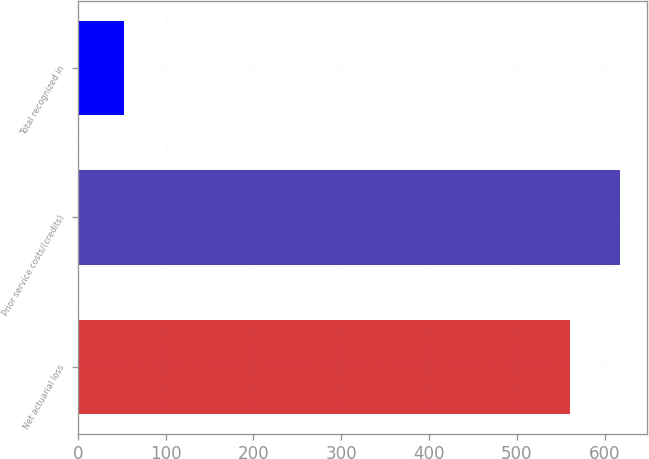Convert chart to OTSL. <chart><loc_0><loc_0><loc_500><loc_500><bar_chart><fcel>Net actuarial loss<fcel>Prior service costs/(credits)<fcel>Total recognized in<nl><fcel>561<fcel>617.1<fcel>53<nl></chart> 